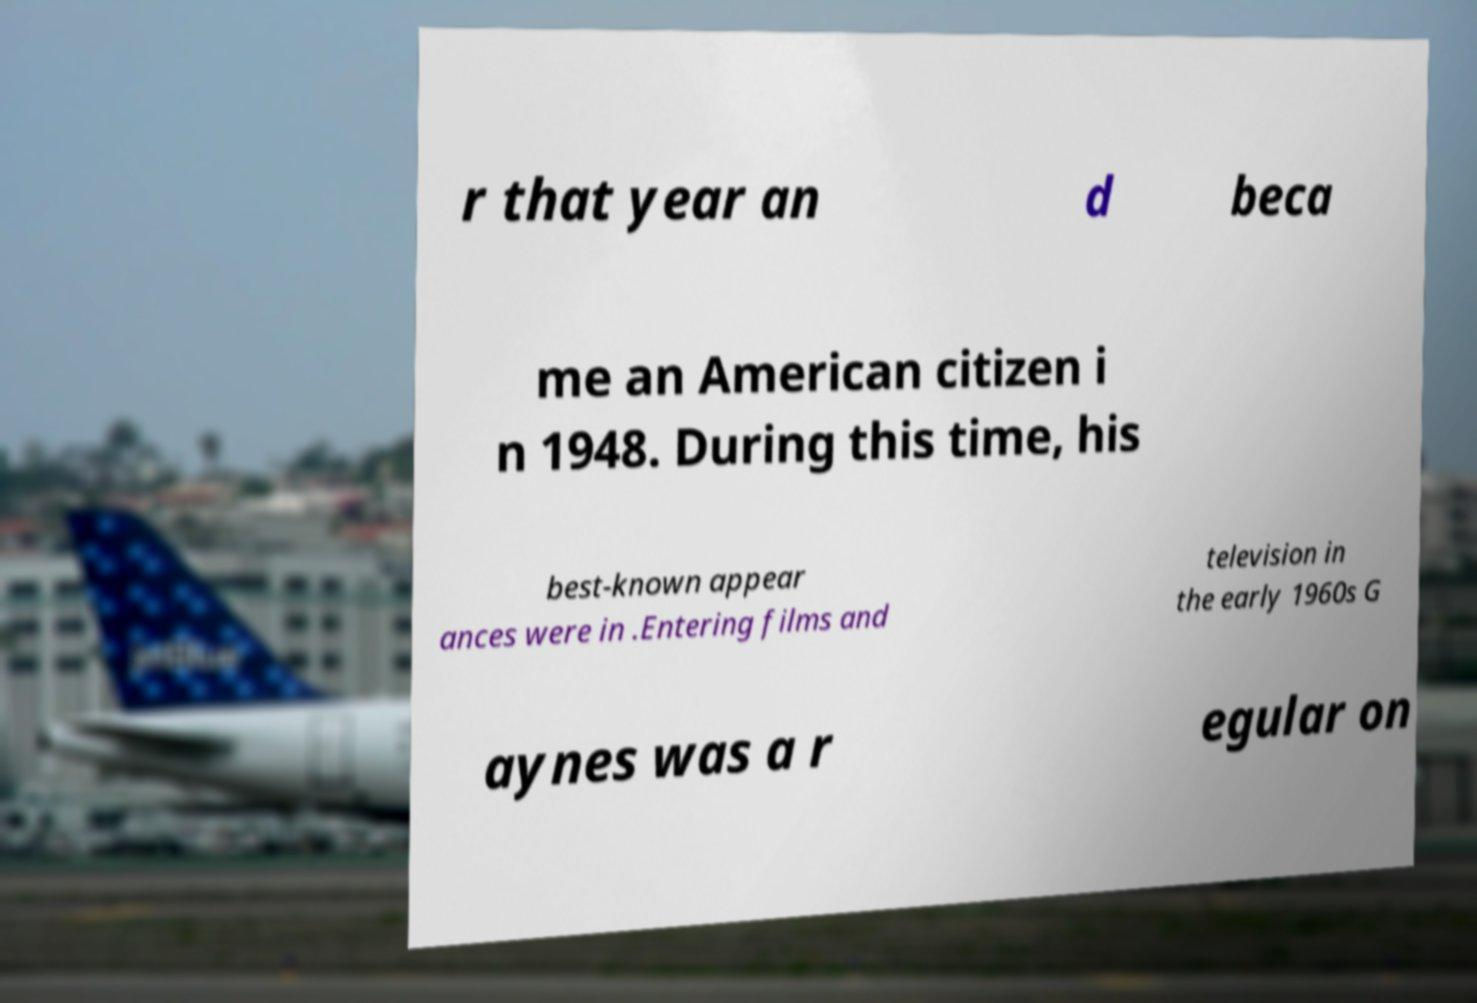Can you read and provide the text displayed in the image?This photo seems to have some interesting text. Can you extract and type it out for me? r that year an d beca me an American citizen i n 1948. During this time, his best-known appear ances were in .Entering films and television in the early 1960s G aynes was a r egular on 